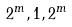<formula> <loc_0><loc_0><loc_500><loc_500>2 ^ { m } , 1 , 2 ^ { m }</formula> 